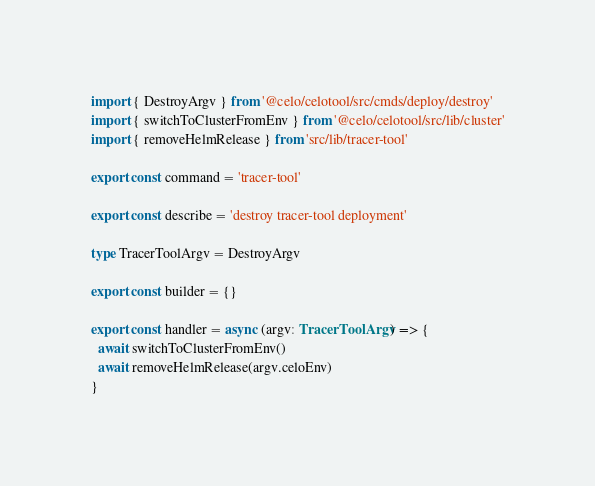<code> <loc_0><loc_0><loc_500><loc_500><_TypeScript_>import { DestroyArgv } from '@celo/celotool/src/cmds/deploy/destroy'
import { switchToClusterFromEnv } from '@celo/celotool/src/lib/cluster'
import { removeHelmRelease } from 'src/lib/tracer-tool'

export const command = 'tracer-tool'

export const describe = 'destroy tracer-tool deployment'

type TracerToolArgv = DestroyArgv

export const builder = {}

export const handler = async (argv: TracerToolArgv) => {
  await switchToClusterFromEnv()
  await removeHelmRelease(argv.celoEnv)
}
</code> 